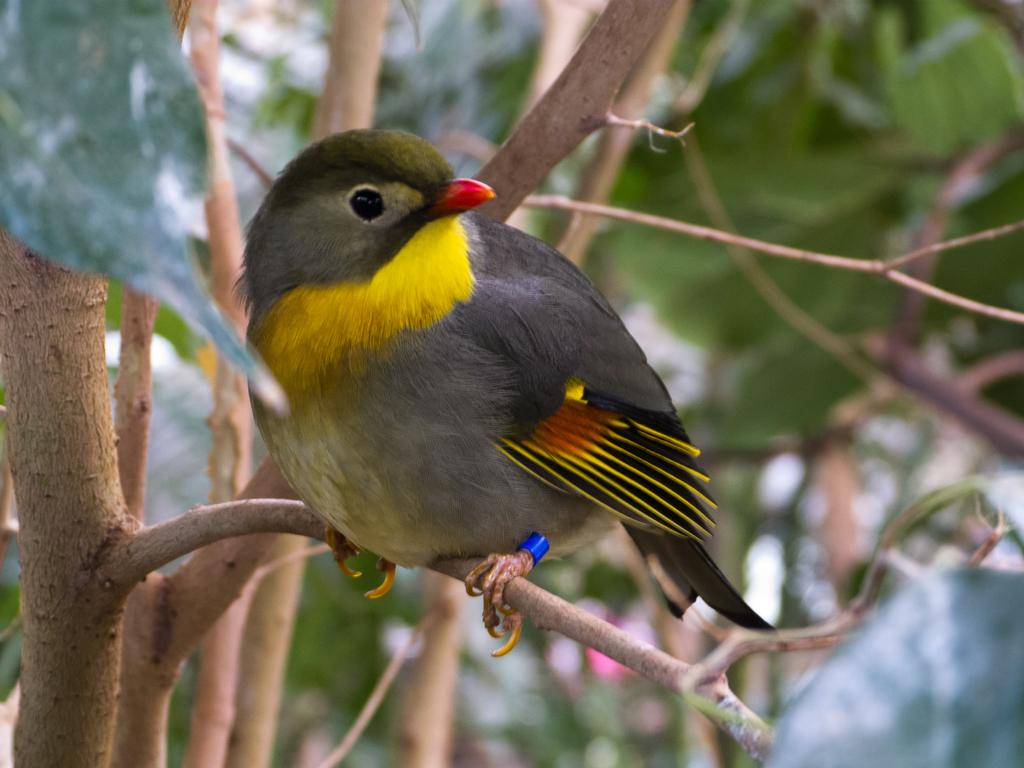What animals can be seen in the image? There are birds on a tree in the image. What colors are the birds? The birds have black, ash, and yellow colors. Can you describe the background of the image? The background of the image is blurred. How many faces can be seen on the birds in the image? There are no faces visible on the birds in the image, as they are birds and not human beings. What type of shoes are the birds wearing on their feet in the image? Birds do not wear shoes, as they are birds and have feet with claws or webbed toes. 